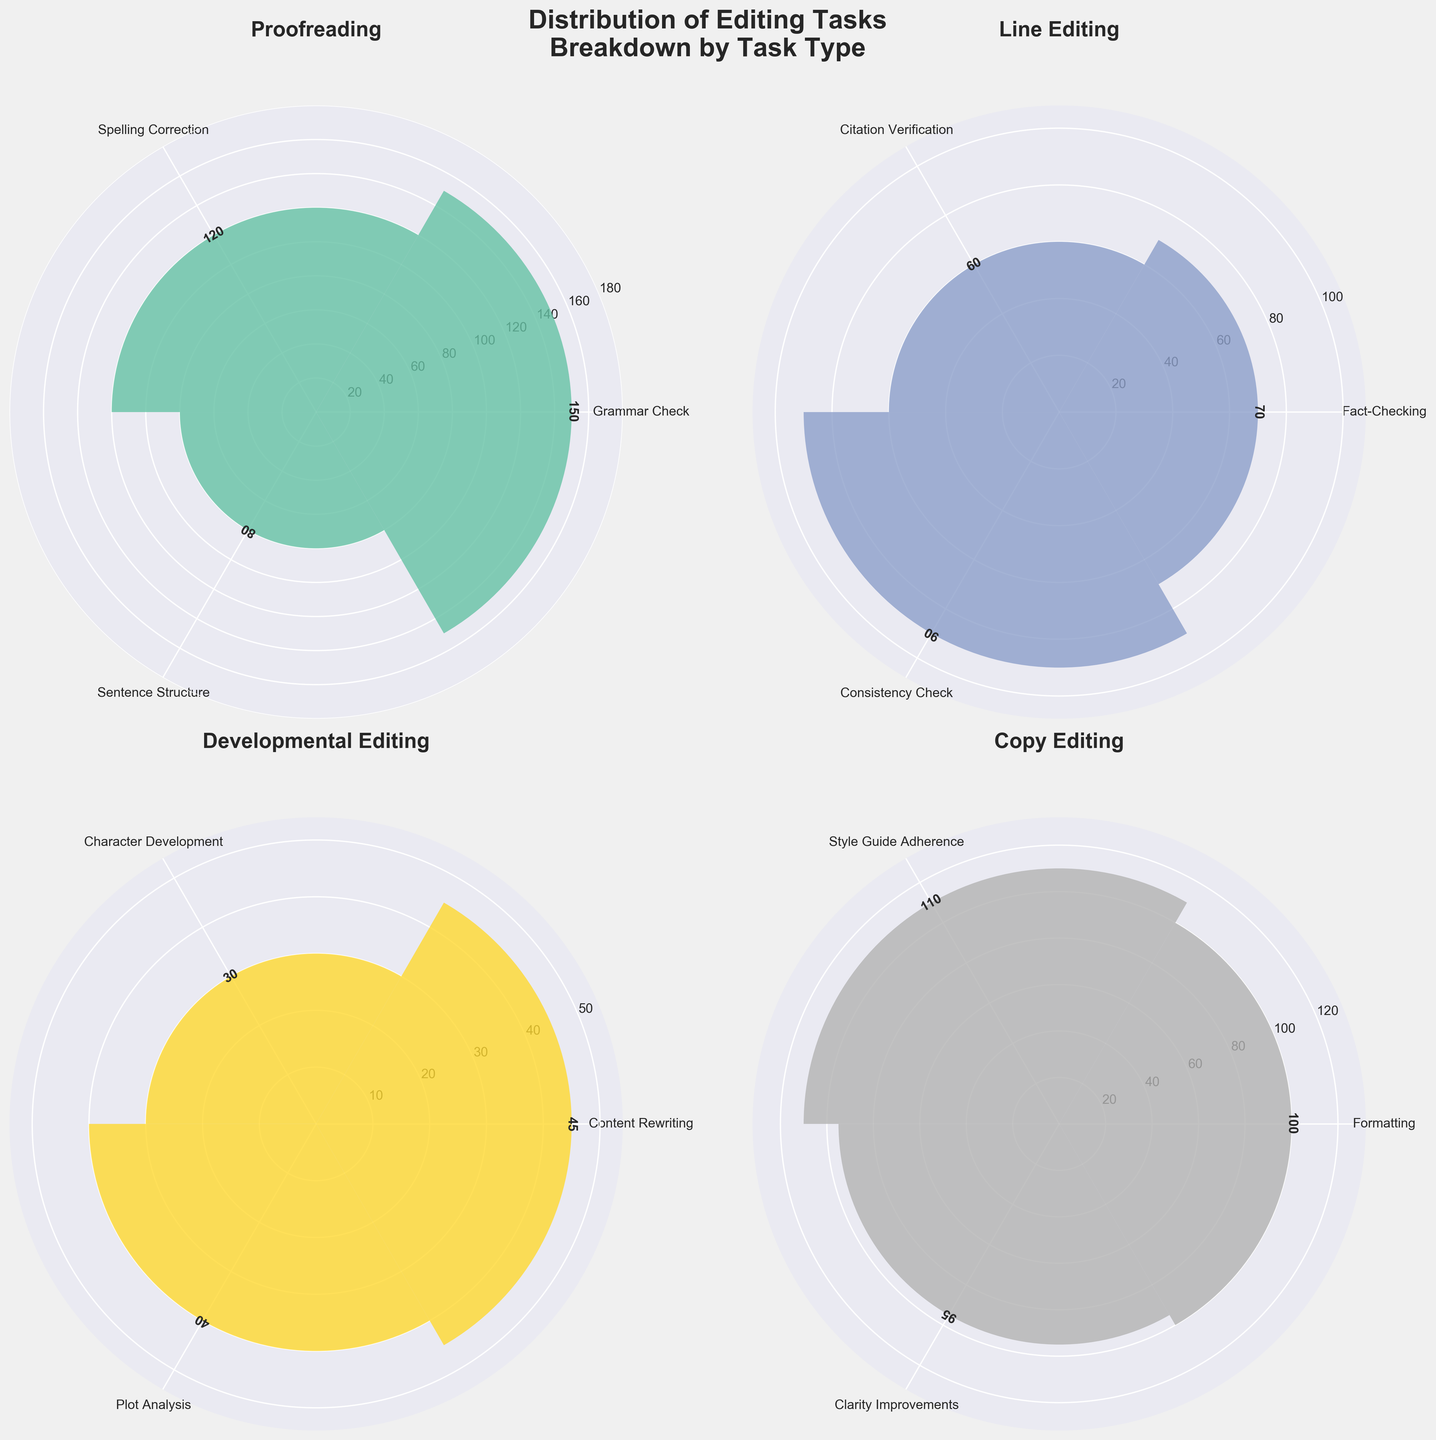How many types of tasks are there in the "Proofreading" category? By looking at the "Proofreading" subplot, count the number of unique labels around the circle. These labels represent different tasks.
Answer: 3 What is the total count of tasks for the "Developmental Editing" category? Sum the values shown for each task in the "Developmental Editing" subplot. The values are 45, 30, and 40. Adding these gives 45 + 30 + 40.
Answer: 115 Which task type has the highest count in the "Copy Editing" category? Identify the tallest bar in the "Copy Editing" subplot and read its labeled task. The tallest bar corresponds to the highest count.
Answer: Style Guide Adherence Is the count of "Clarity Improvements" greater than "Consistency Check"? Compare the counts of "Clarity Improvements" in the "Copy Editing" subplot and "Consistency Check" in the "Line Editing" subplot. The values are 95 and 90, respectively.
Answer: Yes What are the counts for each task in the "Line Editing" category? Read the values displayed next to each bar in the "Line Editing" subplot. The counts are 70, 60, and 90 for the respective tasks.
Answer: 70, 60, 90 Which category has the least total count of tasks? Calculate the total count for each category by summing their respective task counts. Compare: Proofreading (150+120+80), Line Editing (70+60+90), Developmental Editing (45+30+40), Copy Editing (100+110+95). The smallest total is the least.
Answer: Developmental Editing How does the count of "Grammar Check" compare to "Content Rewriting"? Compare the counts of "Grammar Check" in the "Proofreading" subplot (150) and "Content Rewriting" in the "Developmental Editing" subplot (45).
Answer: Grammar Check is greater What is the average task count for the "Proofreading" category? Sum the counts of tasks in the "Proofreading" category: 150, 120, 80. Then divide this sum by the number of tasks: (150 + 120 + 80) / 3.
Answer: 116.67 How many tasks exceed a count of 100? Count the number of tasks across all subplots whose values exceed 100. These include Grammar Check, Style Guide Adherence, and Formatting.
Answer: 3 